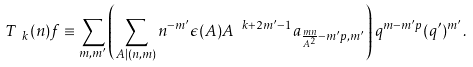Convert formula to latex. <formula><loc_0><loc_0><loc_500><loc_500>T _ { \ k } ( n ) f \equiv \sum _ { m , m ^ { \prime } } \left ( \sum _ { A | ( n , m ) } n ^ { - m ^ { \prime } } \epsilon ( A ) A ^ { \ k + 2 m ^ { \prime } - 1 } a _ { \frac { m n } { A ^ { 2 } } - m ^ { \prime } p , m ^ { \prime } } \right ) q ^ { m - m ^ { \prime } p } ( q ^ { \prime } ) ^ { m ^ { \prime } } .</formula> 